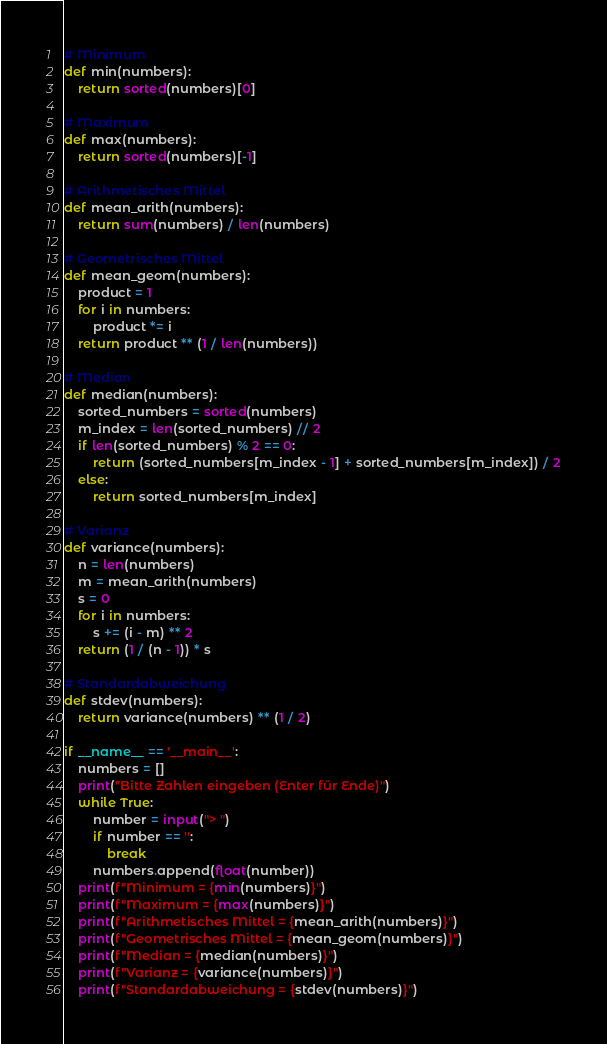Convert code to text. <code><loc_0><loc_0><loc_500><loc_500><_Python_># Minimum
def min(numbers):
    return sorted(numbers)[0]

# Maximum
def max(numbers):
    return sorted(numbers)[-1]

# Arithmetisches Mittel
def mean_arith(numbers):
    return sum(numbers) / len(numbers)

# Geometrisches Mittel
def mean_geom(numbers):
    product = 1
    for i in numbers:
        product *= i
    return product ** (1 / len(numbers))

# Median
def median(numbers):
    sorted_numbers = sorted(numbers)
    m_index = len(sorted_numbers) // 2
    if len(sorted_numbers) % 2 == 0:
        return (sorted_numbers[m_index - 1] + sorted_numbers[m_index]) / 2
    else:
        return sorted_numbers[m_index]

# Varianz
def variance(numbers):
    n = len(numbers)
    m = mean_arith(numbers)
    s = 0
    for i in numbers:
        s += (i - m) ** 2
    return (1 / (n - 1)) * s

# Standardabweichung
def stdev(numbers):
    return variance(numbers) ** (1 / 2)

if __name__ == '__main__':
    numbers = []
    print("Bitte Zahlen eingeben (Enter für Ende)")
    while True:
        number = input("> ")
        if number == '':
            break
        numbers.append(float(number))
    print(f"Minimum = {min(numbers)}")
    print(f"Maximum = {max(numbers)}")
    print(f"Arithmetisches Mittel = {mean_arith(numbers)}")
    print(f"Geometrisches Mittel = {mean_geom(numbers)}")
    print(f"Median = {median(numbers)}")
    print(f"Varianz = {variance(numbers)}")
    print(f"Standardabweichung = {stdev(numbers)}")

</code> 